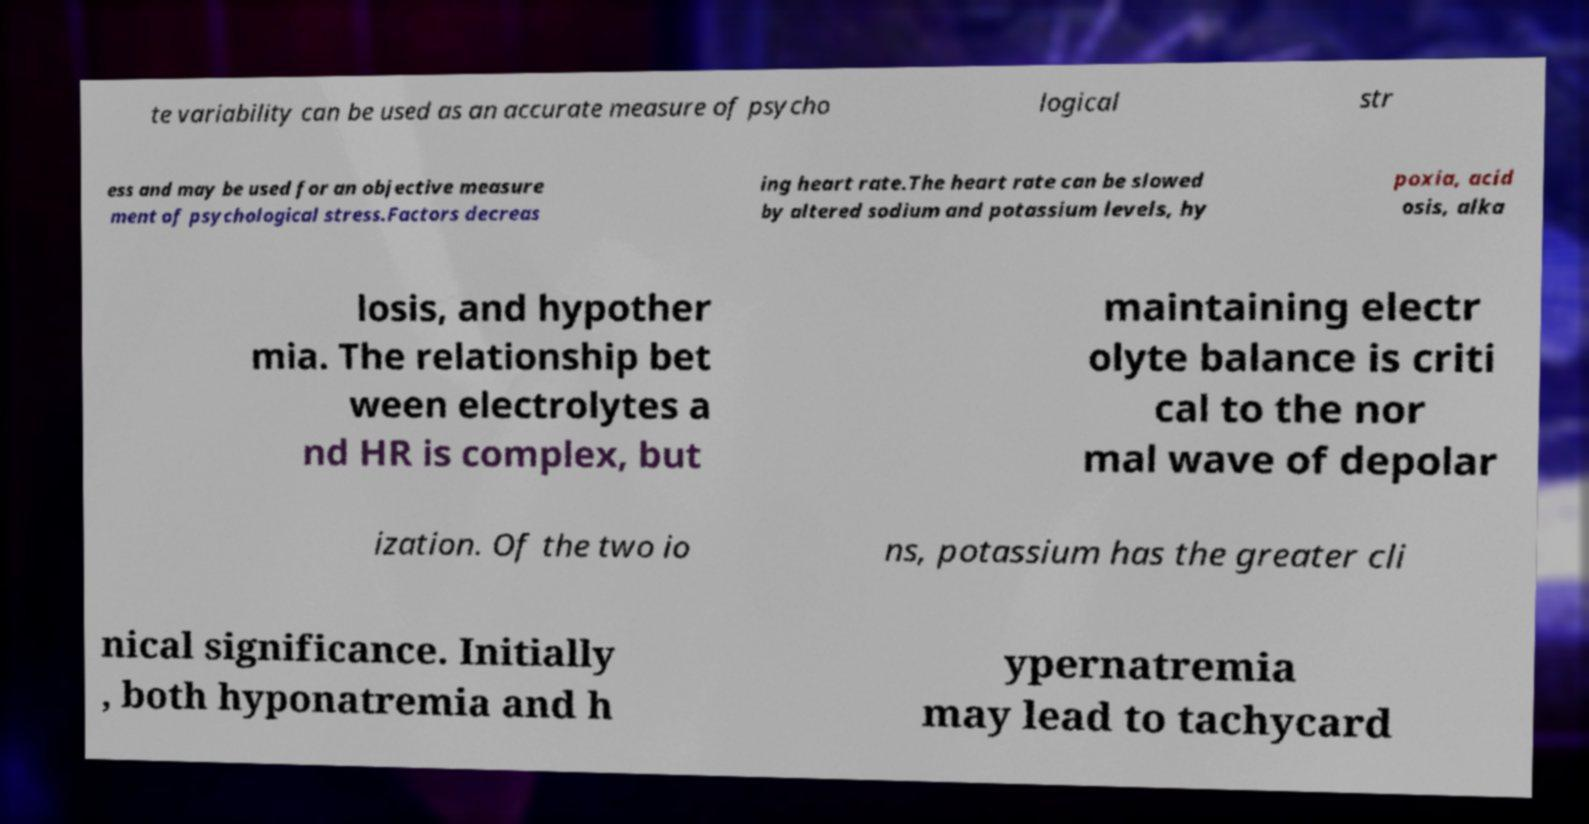Could you assist in decoding the text presented in this image and type it out clearly? te variability can be used as an accurate measure of psycho logical str ess and may be used for an objective measure ment of psychological stress.Factors decreas ing heart rate.The heart rate can be slowed by altered sodium and potassium levels, hy poxia, acid osis, alka losis, and hypother mia. The relationship bet ween electrolytes a nd HR is complex, but maintaining electr olyte balance is criti cal to the nor mal wave of depolar ization. Of the two io ns, potassium has the greater cli nical significance. Initially , both hyponatremia and h ypernatremia may lead to tachycard 